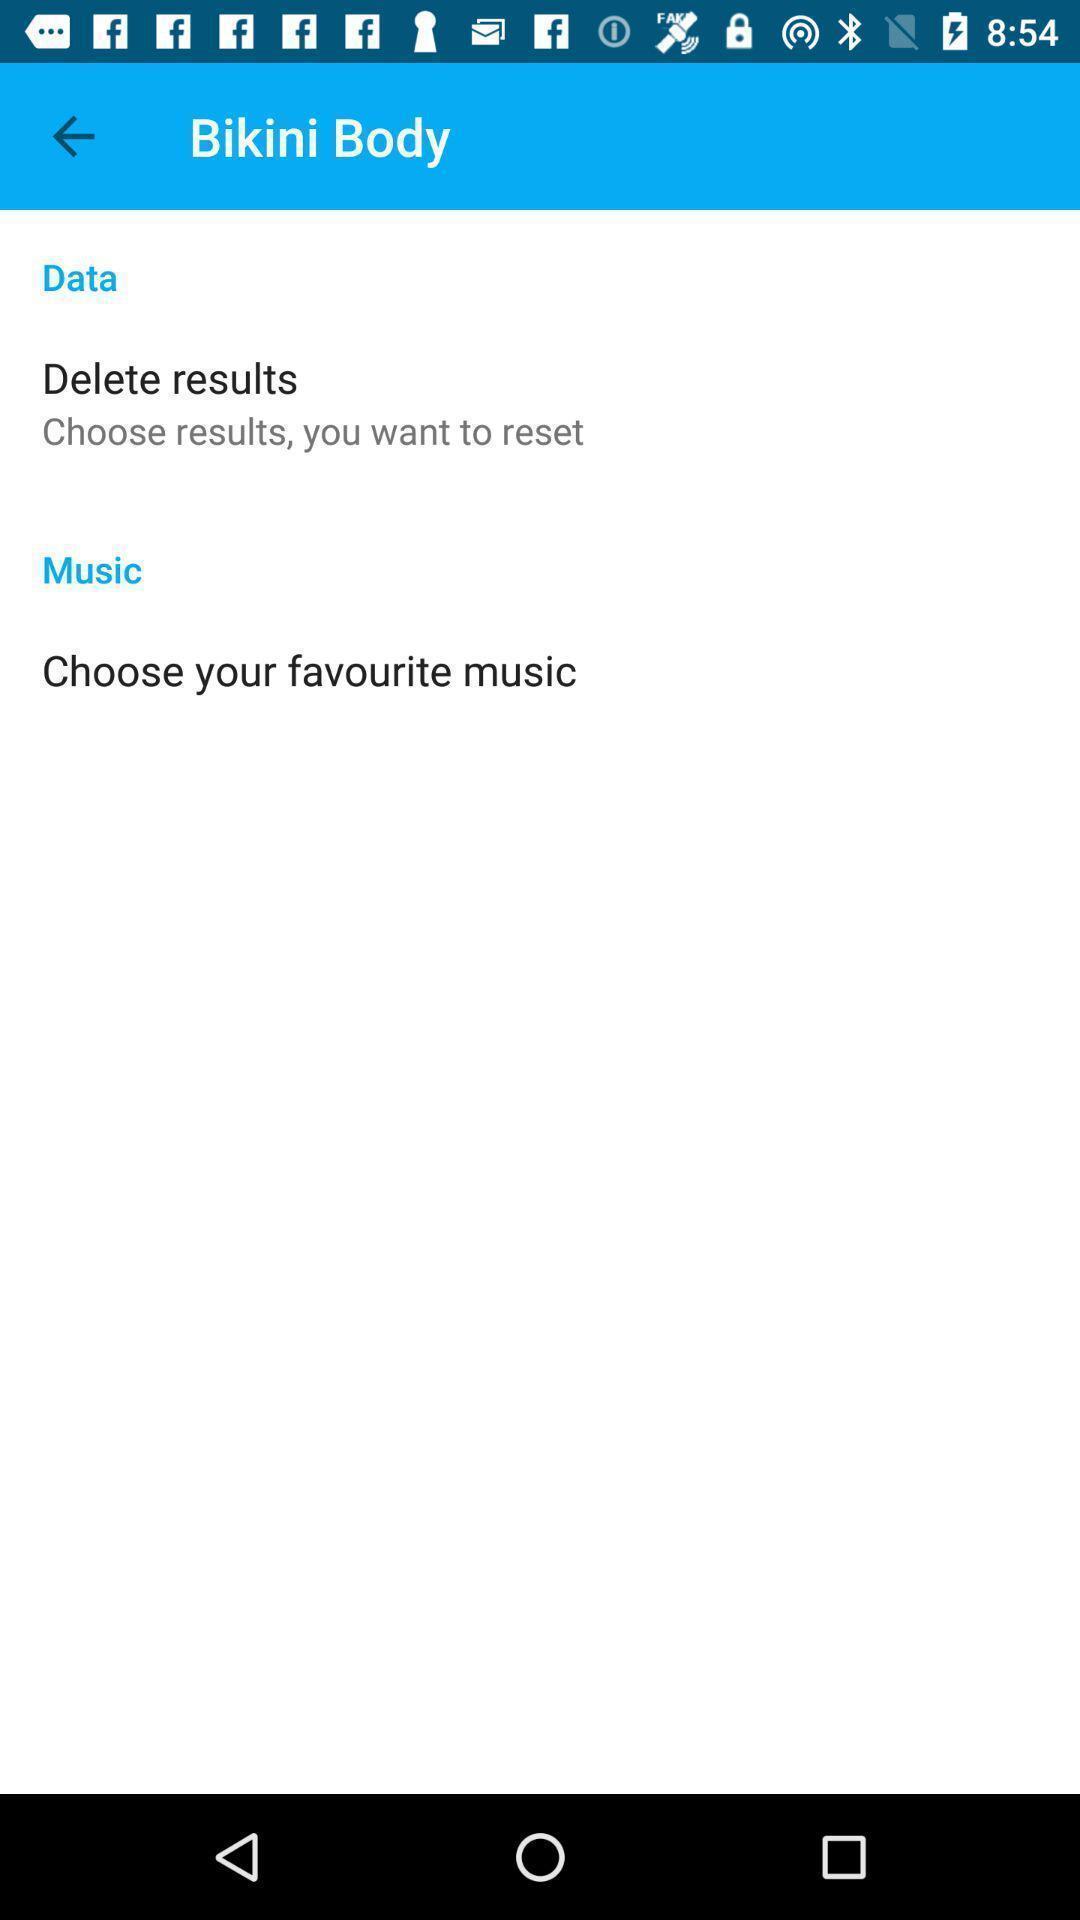Summarize the main components in this picture. Screen displaying to choose music and data. 